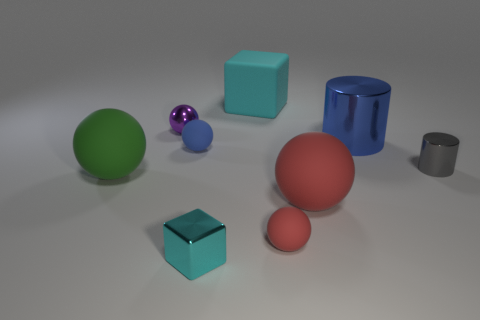What material is the big object that is the same color as the small metal block?
Offer a terse response. Rubber. How many objects are either large spheres that are in front of the green sphere or spheres?
Your answer should be compact. 5. Is the size of the cylinder that is behind the gray metallic cylinder the same as the big cyan rubber thing?
Keep it short and to the point. Yes. Is the number of things that are in front of the small gray cylinder less than the number of small red blocks?
Ensure brevity in your answer.  No. There is a red thing that is the same size as the blue metal cylinder; what material is it?
Ensure brevity in your answer.  Rubber. What number of large things are green things or balls?
Your answer should be very brief. 2. How many things are either spheres that are in front of the large green sphere or matte objects that are in front of the large metal cylinder?
Provide a short and direct response. 4. Are there fewer large green rubber objects than cyan blocks?
Your response must be concise. Yes. The cyan object that is the same size as the green rubber ball is what shape?
Offer a very short reply. Cube. How many other things are the same color as the rubber cube?
Provide a succinct answer. 1. 